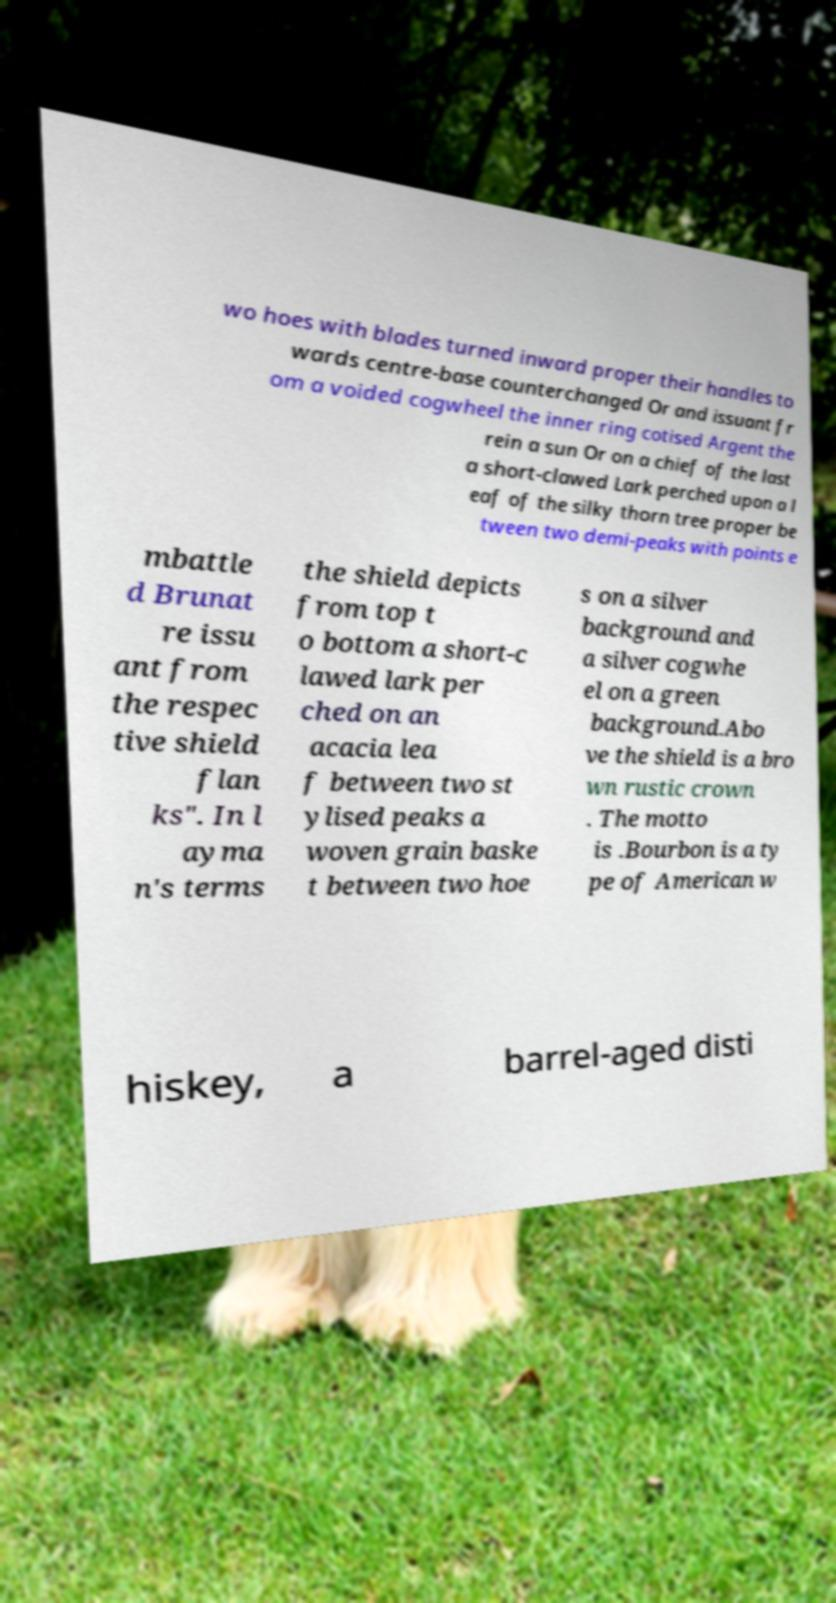Can you read and provide the text displayed in the image?This photo seems to have some interesting text. Can you extract and type it out for me? wo hoes with blades turned inward proper their handles to wards centre-base counterchanged Or and issuant fr om a voided cogwheel the inner ring cotised Argent the rein a sun Or on a chief of the last a short-clawed Lark perched upon a l eaf of the silky thorn tree proper be tween two demi-peaks with points e mbattle d Brunat re issu ant from the respec tive shield flan ks". In l ayma n's terms the shield depicts from top t o bottom a short-c lawed lark per ched on an acacia lea f between two st ylised peaks a woven grain baske t between two hoe s on a silver background and a silver cogwhe el on a green background.Abo ve the shield is a bro wn rustic crown . The motto is .Bourbon is a ty pe of American w hiskey, a barrel-aged disti 